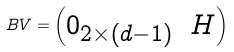<formula> <loc_0><loc_0><loc_500><loc_500>B V = \begin{pmatrix} 0 _ { 2 \times ( d - 1 ) } & H \end{pmatrix}</formula> 